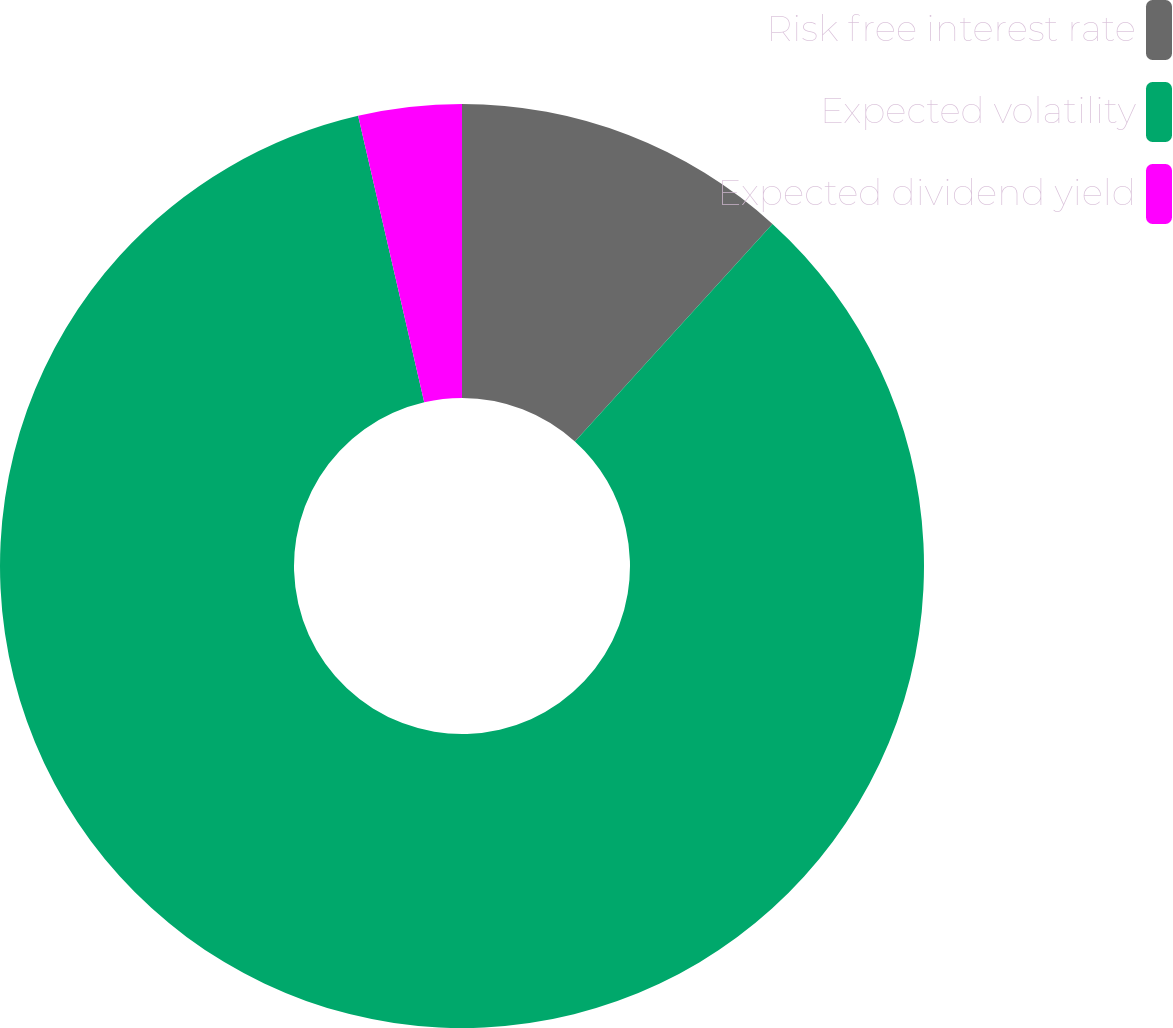Convert chart to OTSL. <chart><loc_0><loc_0><loc_500><loc_500><pie_chart><fcel>Risk free interest rate<fcel>Expected volatility<fcel>Expected dividend yield<nl><fcel>11.73%<fcel>84.67%<fcel>3.61%<nl></chart> 